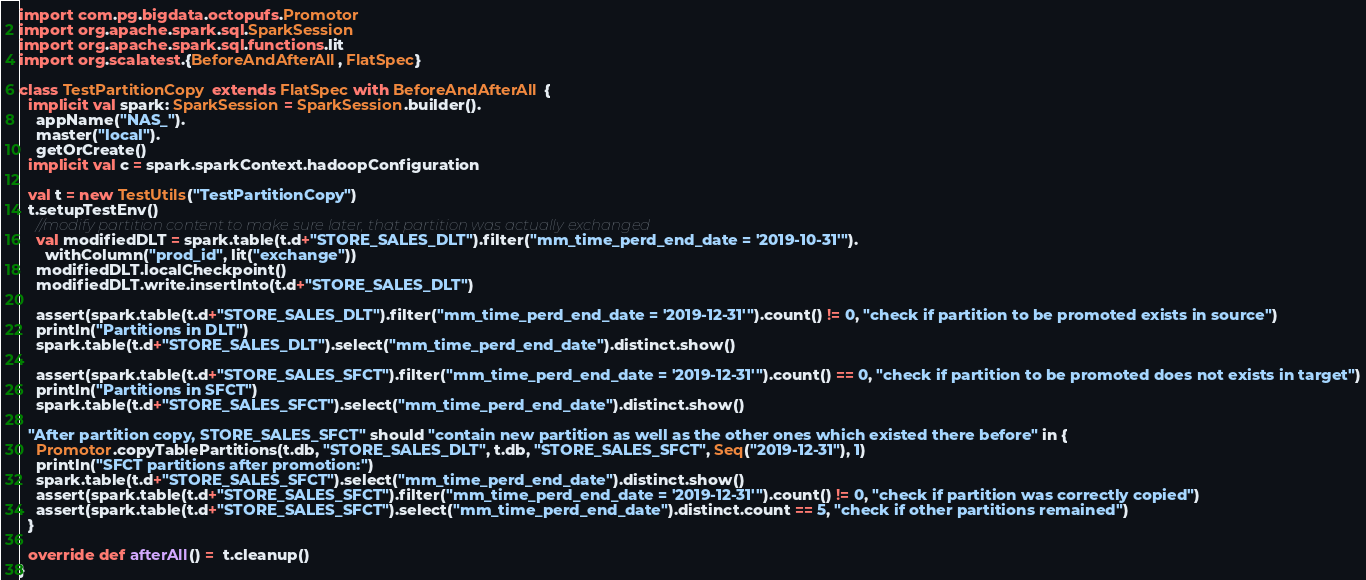Convert code to text. <code><loc_0><loc_0><loc_500><loc_500><_Scala_>import com.pg.bigdata.octopufs.Promotor
import org.apache.spark.sql.SparkSession
import org.apache.spark.sql.functions.lit
import org.scalatest.{BeforeAndAfterAll, FlatSpec}

class TestPartitionCopy extends FlatSpec with BeforeAndAfterAll {
  implicit val spark: SparkSession = SparkSession.builder().
    appName("NAS_").
    master("local").
    getOrCreate()
  implicit val c = spark.sparkContext.hadoopConfiguration

  val t = new TestUtils("TestPartitionCopy")
  t.setupTestEnv()
    //modify partition content to make sure later, that partition was actually exchanged
    val modifiedDLT = spark.table(t.d+"STORE_SALES_DLT").filter("mm_time_perd_end_date = '2019-10-31'").
      withColumn("prod_id", lit("exchange"))
    modifiedDLT.localCheckpoint()
    modifiedDLT.write.insertInto(t.d+"STORE_SALES_DLT")

    assert(spark.table(t.d+"STORE_SALES_DLT").filter("mm_time_perd_end_date = '2019-12-31'").count() != 0, "check if partition to be promoted exists in source")
    println("Partitions in DLT")
    spark.table(t.d+"STORE_SALES_DLT").select("mm_time_perd_end_date").distinct.show()

    assert(spark.table(t.d+"STORE_SALES_SFCT").filter("mm_time_perd_end_date = '2019-12-31'").count() == 0, "check if partition to be promoted does not exists in target")
    println("Partitions in SFCT")
    spark.table(t.d+"STORE_SALES_SFCT").select("mm_time_perd_end_date").distinct.show()

  "After partition copy, STORE_SALES_SFCT" should "contain new partition as well as the other ones which existed there before" in {
    Promotor.copyTablePartitions(t.db, "STORE_SALES_DLT", t.db, "STORE_SALES_SFCT", Seq("2019-12-31"), 1)
    println("SFCT partitions after promotion:")
    spark.table(t.d+"STORE_SALES_SFCT").select("mm_time_perd_end_date").distinct.show()
    assert(spark.table(t.d+"STORE_SALES_SFCT").filter("mm_time_perd_end_date = '2019-12-31'").count() != 0, "check if partition was correctly copied")
    assert(spark.table(t.d+"STORE_SALES_SFCT").select("mm_time_perd_end_date").distinct.count == 5, "check if other partitions remained")
  }

  override def afterAll() =  t.cleanup()
}
</code> 